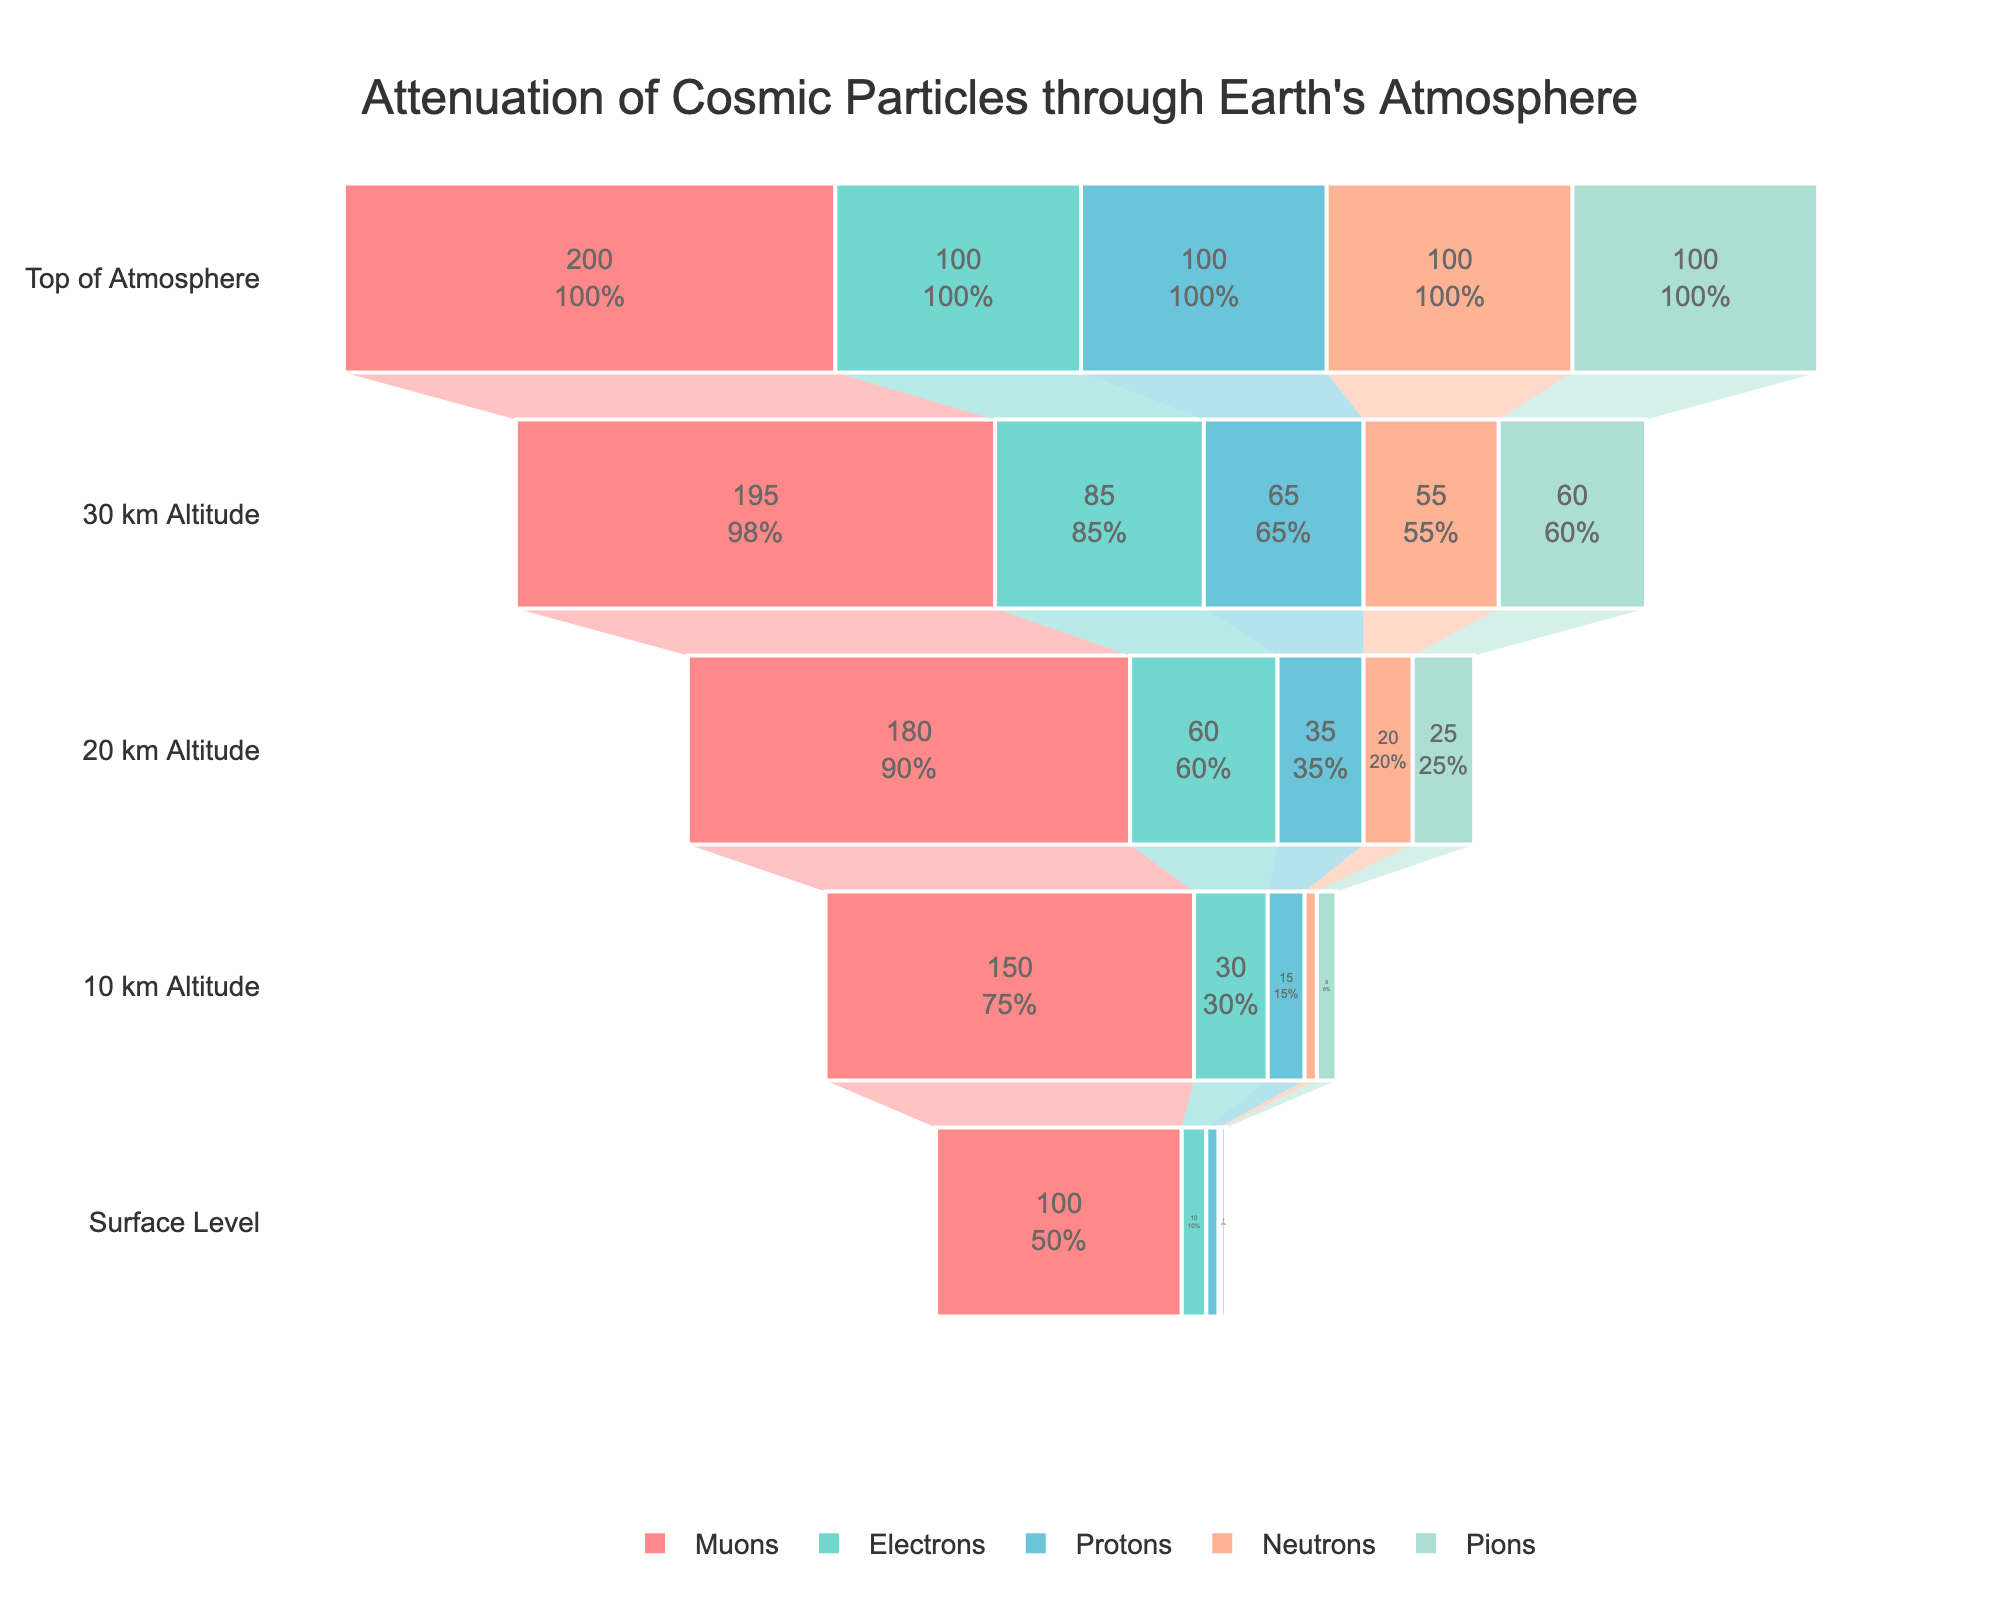How many particle types are depicted in the chart? The chart includes data for different particle types represented by distinct colors.
Answer: 5 What is the title of the chart? The title is displayed at the top of the chart.
Answer: Attenuation of Cosmic Particles through Earth's Atmosphere Which particle type has the highest intensity at the surface level? By looking at the surface level values for all particle types, the Muons have the highest value of 100.
Answer: Muons For Muons, what is the percentage reduction in intensity from the top of the atmosphere to the surface level? The intensity at the top of the atmosphere is 200 and 100 at the surface level. The percentage reduction is ((200 - 100) / 200) * 100%.
Answer: 50% Which particle type shows the least attenuation from the top of the atmosphere to the surface level? Comparing the percentage drops from top to the surface for each particle type, Muons show the least attenuation.
Answer: Muons What is the intensity of Neutrons at 30 km altitude? The Neuron's intensity at 30 km is given by the chart value at that level.
Answer: 55 Compare the intensity of Electrons and Protons at 20 km altitude. Which one is higher? Electrons have an intensity of 60 and Protons have an intensity of 35 at 20 km altitude. 60 > 35.
Answer: Electrons What is the average intensity of Pions across all altitudes? Summing up the values for Pions gives 2 + 8 + 25 + 60 + 100 = 195. Dividing by 5 altitude levels results in an average of 195/5.
Answer: 39 At what altitude does the intensity of Muons first surpass 180? Going through the levels, at 20 km altitude, the intensity of Muons is 180. At the next level, 10 km, it's 150, so it's at 20 km altitude.
Answer: 20 km Which particle type has an intensity of exactly 100 at the top of the atmosphere and 60 at 20 km altitude? Only Protons show an intensity of 100 at the top of the atmosphere and exactly 60 at the 20 km level.
Answer: Protons 